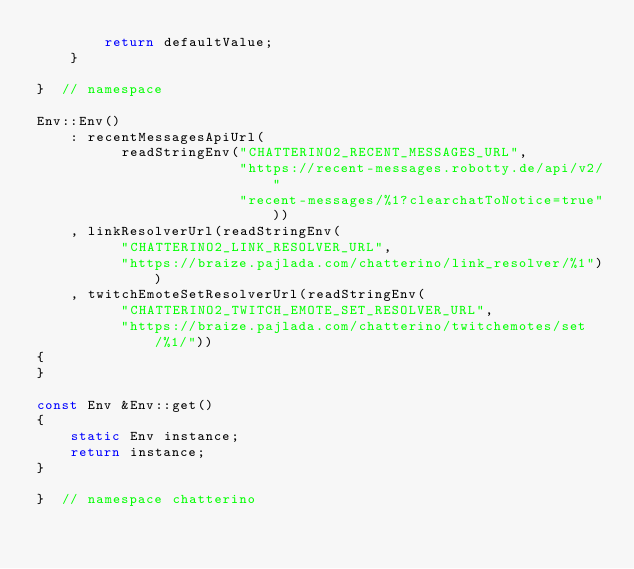<code> <loc_0><loc_0><loc_500><loc_500><_C++_>        return defaultValue;
    }

}  // namespace

Env::Env()
    : recentMessagesApiUrl(
          readStringEnv("CHATTERINO2_RECENT_MESSAGES_URL",
                        "https://recent-messages.robotty.de/api/v2/"
                        "recent-messages/%1?clearchatToNotice=true"))
    , linkResolverUrl(readStringEnv(
          "CHATTERINO2_LINK_RESOLVER_URL",
          "https://braize.pajlada.com/chatterino/link_resolver/%1"))
    , twitchEmoteSetResolverUrl(readStringEnv(
          "CHATTERINO2_TWITCH_EMOTE_SET_RESOLVER_URL",
          "https://braize.pajlada.com/chatterino/twitchemotes/set/%1/"))
{
}

const Env &Env::get()
{
    static Env instance;
    return instance;
}

}  // namespace chatterino
</code> 